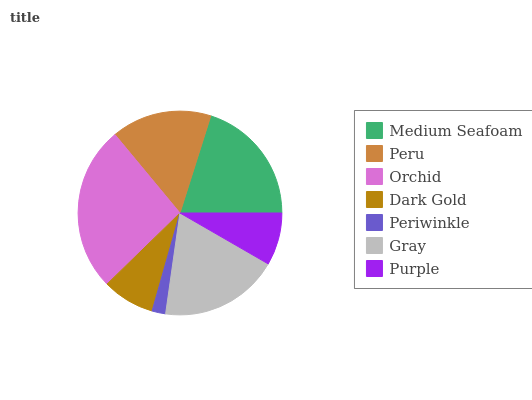Is Periwinkle the minimum?
Answer yes or no. Yes. Is Orchid the maximum?
Answer yes or no. Yes. Is Peru the minimum?
Answer yes or no. No. Is Peru the maximum?
Answer yes or no. No. Is Medium Seafoam greater than Peru?
Answer yes or no. Yes. Is Peru less than Medium Seafoam?
Answer yes or no. Yes. Is Peru greater than Medium Seafoam?
Answer yes or no. No. Is Medium Seafoam less than Peru?
Answer yes or no. No. Is Peru the high median?
Answer yes or no. Yes. Is Peru the low median?
Answer yes or no. Yes. Is Gray the high median?
Answer yes or no. No. Is Medium Seafoam the low median?
Answer yes or no. No. 